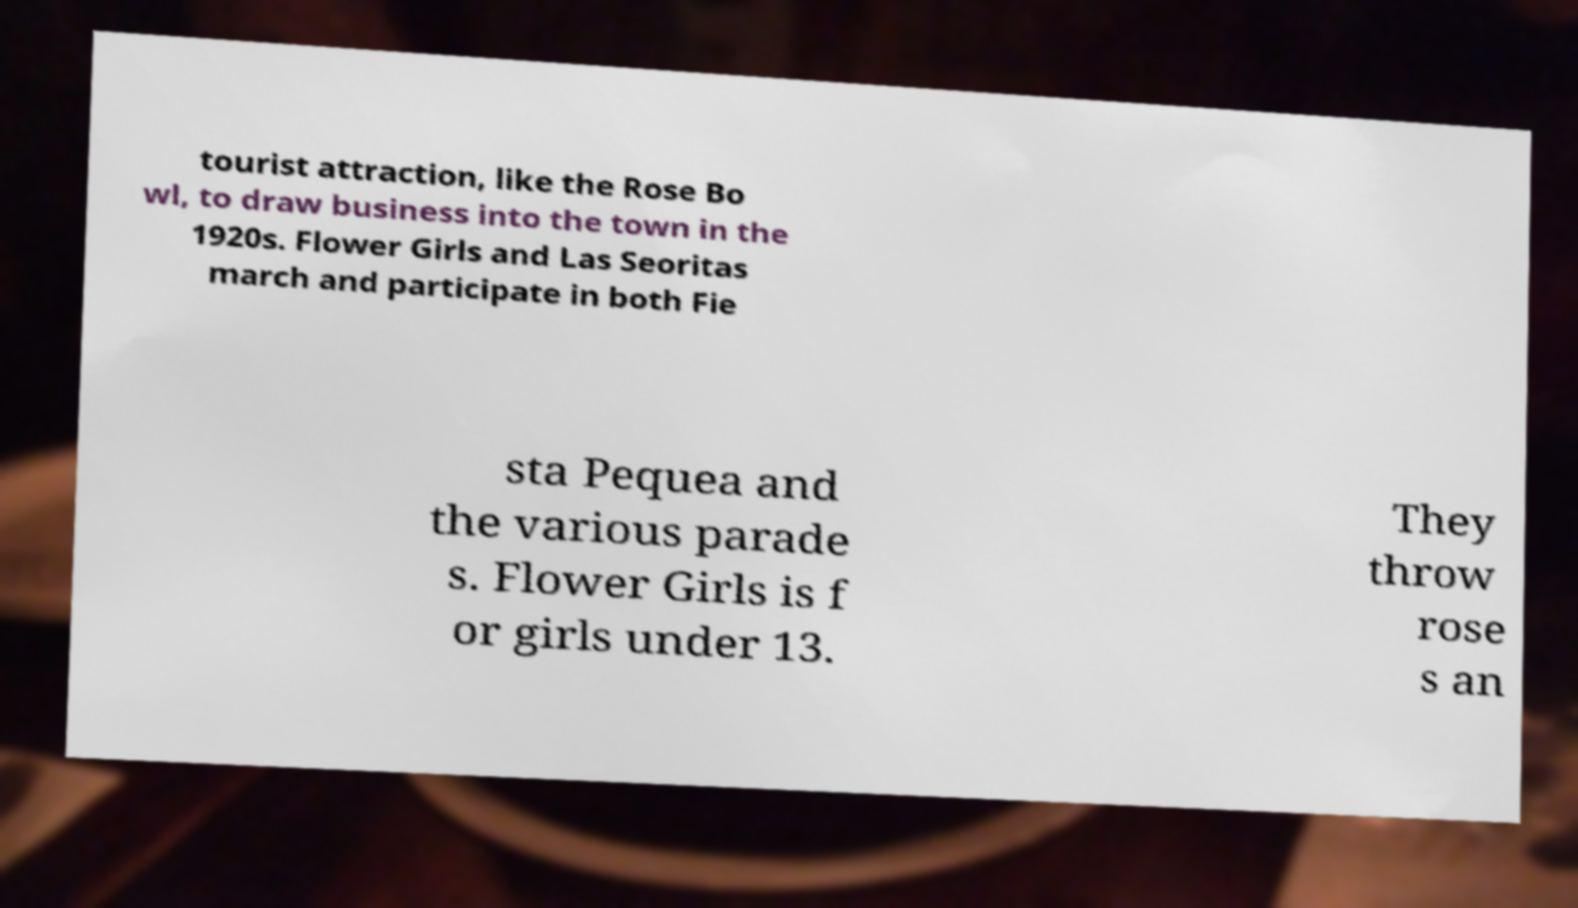Can you accurately transcribe the text from the provided image for me? tourist attraction, like the Rose Bo wl, to draw business into the town in the 1920s. Flower Girls and Las Seoritas march and participate in both Fie sta Pequea and the various parade s. Flower Girls is f or girls under 13. They throw rose s an 